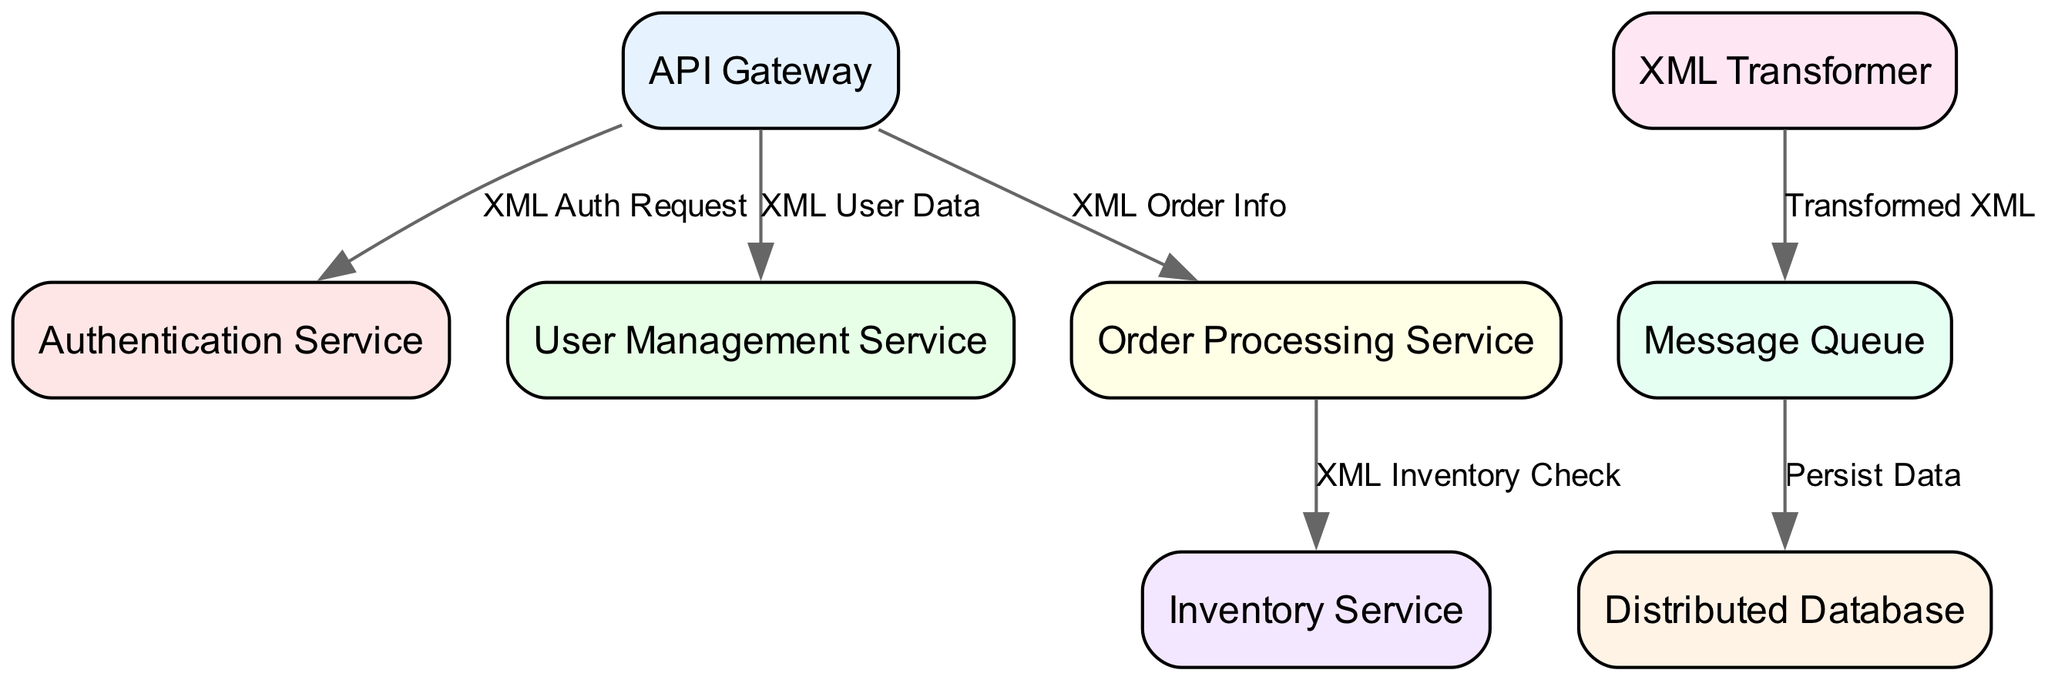What is the total number of nodes in the diagram? There are a total of eight nodes listed in the data: API Gateway, Authentication Service, User Management Service, Order Processing Service, Inventory Service, XML Transformer, Message Queue, and Distributed Database.
Answer: Eight What type of request is sent from the API Gateway to the Authentication Service? The edge connecting the API Gateway to the Authentication Service is labeled "XML Auth Request," indicating the type of request.
Answer: XML Auth Request Which microservice is responsible for processing orders? The diagram indicates that the Order Processing Service is directly connected to the API Gateway, serving as the service handling orders.
Answer: Order Processing Service How does the XML Transformer interact with the rest of the architecture? The XML Transformer connects to the Message Queue, indicated by the edge labeled "Transformed XML," showing that it outputs XML data that is queued for further processing.
Answer: Via Message Queue What is the label of the connection between the Order Processing Service and Inventory Service? The edge connecting the Order Processing Service to the Inventory Service is labeled "XML Inventory Check", which describes the function of that connection in the microservices architecture.
Answer: XML Inventory Check How many edges connect the API Gateway to other services? The API Gateway has three outgoing edges connecting it to the Authentication Service, User Management Service, and Order Processing Service, indicating it has direct communication with three services.
Answer: Three What is the final action taken after data is published to the Message Queue? The Message Queue connects to a node labeled "Distributed Database" with the edge labeled "Persist Data," indicating that the final action is to save the data.
Answer: Persist Data Which component transmits transformed XML data? The XML Transformer component has an outgoing edge to the Message Queue labeled "Transformed XML," confirming that it transmits the transformed XML data.
Answer: XML Transformer 